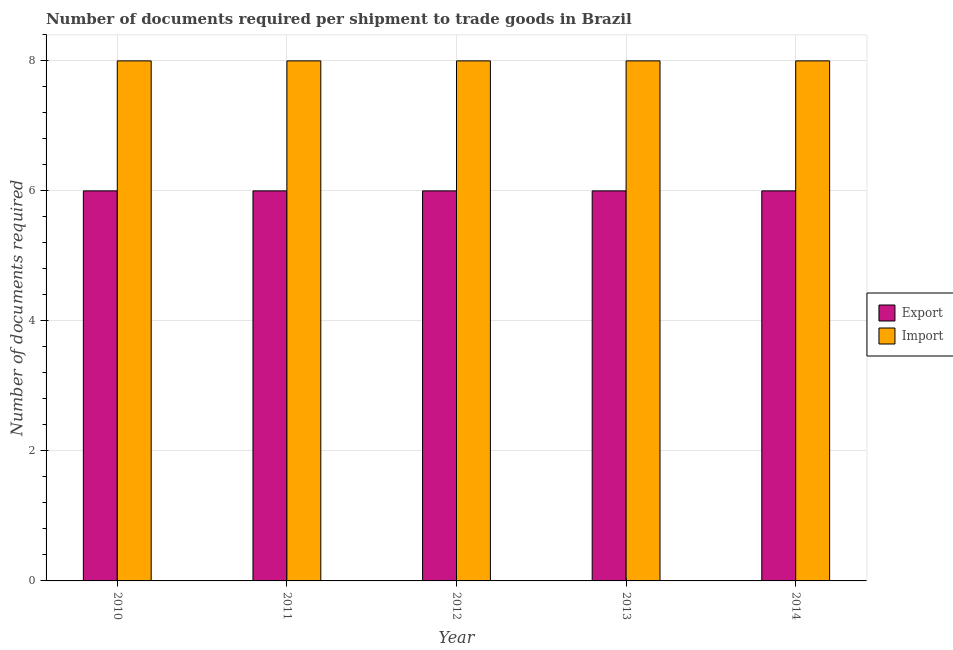How many different coloured bars are there?
Offer a terse response. 2. Are the number of bars per tick equal to the number of legend labels?
Offer a very short reply. Yes. How many bars are there on the 4th tick from the left?
Your response must be concise. 2. How many bars are there on the 3rd tick from the right?
Keep it short and to the point. 2. What is the number of documents required to export goods in 2011?
Keep it short and to the point. 6. Across all years, what is the maximum number of documents required to export goods?
Offer a terse response. 6. What is the total number of documents required to import goods in the graph?
Offer a very short reply. 40. What is the difference between the number of documents required to import goods in 2012 and that in 2014?
Your answer should be compact. 0. What is the difference between the number of documents required to import goods in 2013 and the number of documents required to export goods in 2014?
Provide a succinct answer. 0. In the year 2011, what is the difference between the number of documents required to import goods and number of documents required to export goods?
Offer a terse response. 0. In how many years, is the number of documents required to export goods greater than 2?
Provide a succinct answer. 5. Is the difference between the number of documents required to import goods in 2013 and 2014 greater than the difference between the number of documents required to export goods in 2013 and 2014?
Keep it short and to the point. No. What is the difference between the highest and the second highest number of documents required to import goods?
Your response must be concise. 0. In how many years, is the number of documents required to import goods greater than the average number of documents required to import goods taken over all years?
Make the answer very short. 0. What does the 2nd bar from the left in 2013 represents?
Ensure brevity in your answer.  Import. What does the 1st bar from the right in 2014 represents?
Provide a succinct answer. Import. How many bars are there?
Your answer should be very brief. 10. Are all the bars in the graph horizontal?
Offer a terse response. No. What is the difference between two consecutive major ticks on the Y-axis?
Make the answer very short. 2. Does the graph contain any zero values?
Your answer should be compact. No. Does the graph contain grids?
Keep it short and to the point. Yes. How many legend labels are there?
Your response must be concise. 2. What is the title of the graph?
Offer a terse response. Number of documents required per shipment to trade goods in Brazil. Does "Health Care" appear as one of the legend labels in the graph?
Offer a terse response. No. What is the label or title of the X-axis?
Provide a succinct answer. Year. What is the label or title of the Y-axis?
Your response must be concise. Number of documents required. What is the Number of documents required in Import in 2010?
Make the answer very short. 8. What is the Number of documents required in Export in 2011?
Offer a terse response. 6. What is the Number of documents required in Export in 2012?
Your answer should be compact. 6. What is the Number of documents required in Import in 2012?
Your answer should be very brief. 8. What is the Number of documents required of Import in 2013?
Make the answer very short. 8. What is the Number of documents required of Import in 2014?
Provide a succinct answer. 8. Across all years, what is the maximum Number of documents required of Export?
Your answer should be compact. 6. Across all years, what is the minimum Number of documents required of Import?
Make the answer very short. 8. What is the difference between the Number of documents required in Export in 2010 and that in 2011?
Your response must be concise. 0. What is the difference between the Number of documents required in Import in 2010 and that in 2012?
Offer a very short reply. 0. What is the difference between the Number of documents required in Export in 2010 and that in 2014?
Your answer should be very brief. 0. What is the difference between the Number of documents required of Export in 2011 and that in 2012?
Offer a terse response. 0. What is the difference between the Number of documents required of Import in 2011 and that in 2012?
Give a very brief answer. 0. What is the difference between the Number of documents required of Export in 2011 and that in 2014?
Provide a succinct answer. 0. What is the difference between the Number of documents required in Import in 2011 and that in 2014?
Provide a short and direct response. 0. What is the difference between the Number of documents required in Export in 2012 and that in 2014?
Give a very brief answer. 0. What is the difference between the Number of documents required of Import in 2012 and that in 2014?
Provide a succinct answer. 0. What is the difference between the Number of documents required of Import in 2013 and that in 2014?
Provide a short and direct response. 0. What is the difference between the Number of documents required in Export in 2010 and the Number of documents required in Import in 2012?
Keep it short and to the point. -2. What is the difference between the Number of documents required of Export in 2010 and the Number of documents required of Import in 2014?
Your answer should be compact. -2. What is the difference between the Number of documents required in Export in 2011 and the Number of documents required in Import in 2014?
Provide a short and direct response. -2. What is the difference between the Number of documents required of Export in 2012 and the Number of documents required of Import in 2014?
Keep it short and to the point. -2. What is the difference between the Number of documents required of Export in 2013 and the Number of documents required of Import in 2014?
Your response must be concise. -2. What is the average Number of documents required in Export per year?
Provide a short and direct response. 6. What is the average Number of documents required of Import per year?
Offer a terse response. 8. In the year 2010, what is the difference between the Number of documents required in Export and Number of documents required in Import?
Make the answer very short. -2. In the year 2012, what is the difference between the Number of documents required of Export and Number of documents required of Import?
Keep it short and to the point. -2. What is the ratio of the Number of documents required in Import in 2010 to that in 2013?
Give a very brief answer. 1. What is the ratio of the Number of documents required in Export in 2010 to that in 2014?
Keep it short and to the point. 1. What is the ratio of the Number of documents required of Export in 2012 to that in 2013?
Offer a very short reply. 1. What is the ratio of the Number of documents required in Import in 2012 to that in 2013?
Offer a terse response. 1. What is the ratio of the Number of documents required of Export in 2012 to that in 2014?
Your answer should be very brief. 1. What is the ratio of the Number of documents required of Import in 2012 to that in 2014?
Your answer should be very brief. 1. What is the difference between the highest and the second highest Number of documents required in Export?
Ensure brevity in your answer.  0. What is the difference between the highest and the second highest Number of documents required in Import?
Your answer should be very brief. 0. What is the difference between the highest and the lowest Number of documents required in Export?
Make the answer very short. 0. 